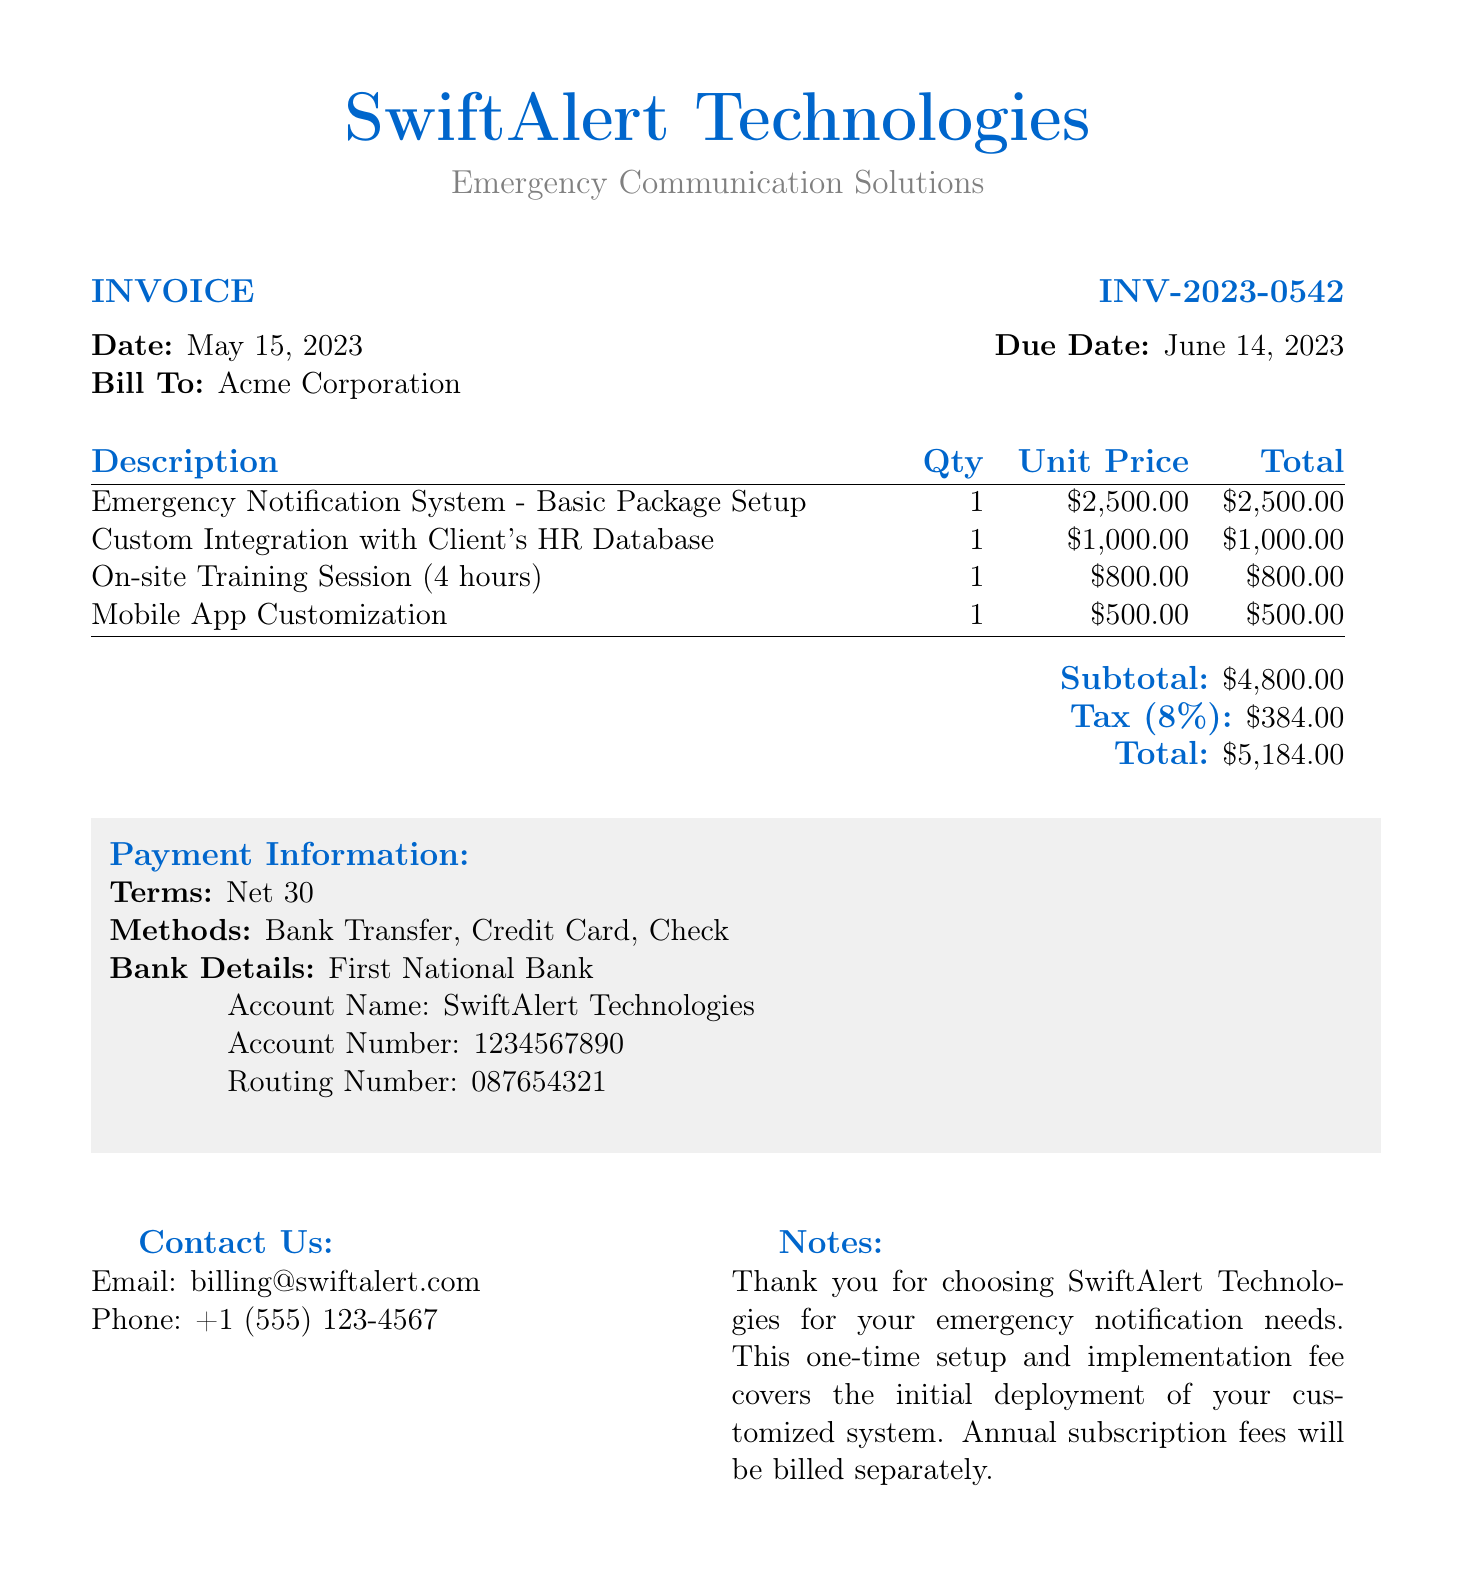What is the invoice number? The invoice number is clearly listed in the document as INV-2023-0542.
Answer: INV-2023-0542 What is the date of the invoice? The document specifies the date of the invoice, which is May 15, 2023.
Answer: May 15, 2023 Who is the bill to? The recipient of the bill is identified as Acme Corporation.
Answer: Acme Corporation What is the total amount due? The total amount can be found in the totals section under "Total," which is $5,184.00.
Answer: $5,184.00 What is the tax percentage applied? The tax percentage is stated in the document as 8%.
Answer: 8% How much is the subtotal before tax? The subtotal is noted in the corresponding section as $4,800.00.
Answer: $4,800.00 What is included in the one-time setup fees? The description section lists a variety of services included in the one-time setup fees.
Answer: Emergency Notification System - Basic Package Setup, Custom Integration with Client's HR Database, On-site Training Session, Mobile App Customization What are the accepted payment methods? The payment methods are listed as Bank Transfer, Credit Card, and Check.
Answer: Bank Transfer, Credit Card, Check What are the payment terms stated in the document? The payment terms are specified in the payment information section as Net 30.
Answer: Net 30 